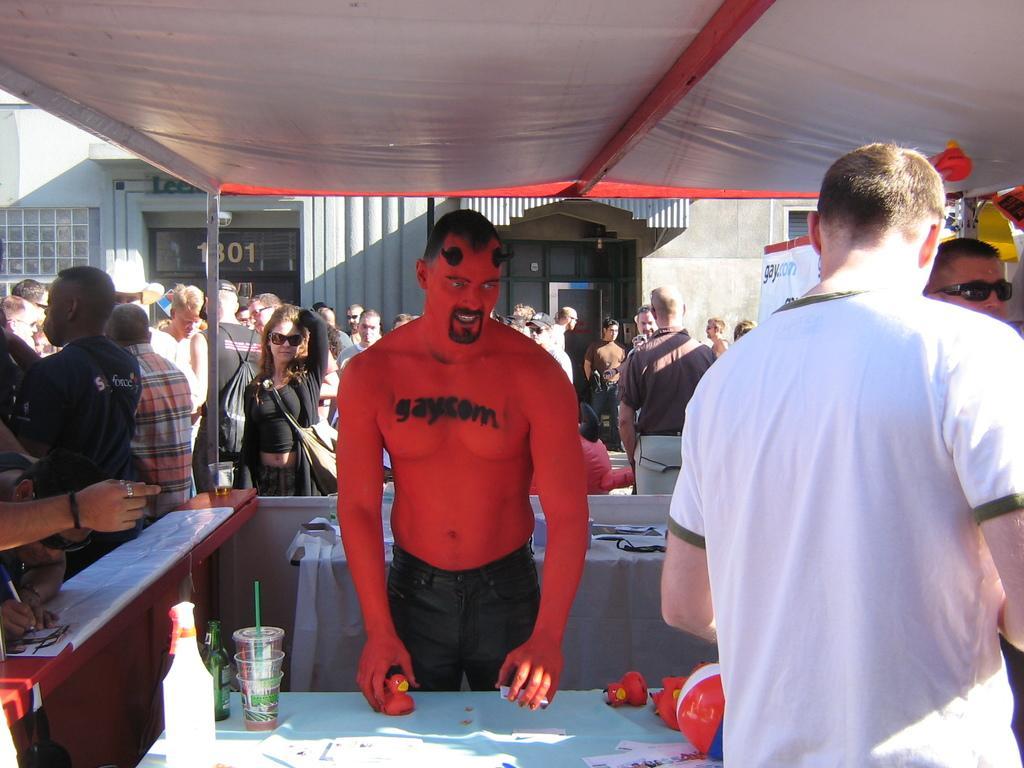Describe this image in one or two sentences. There is a stall and inside the stall there are there people standing and outside the stall there is a crowd and behind them there is store and there is a lot of sunlight falling on the ground. 